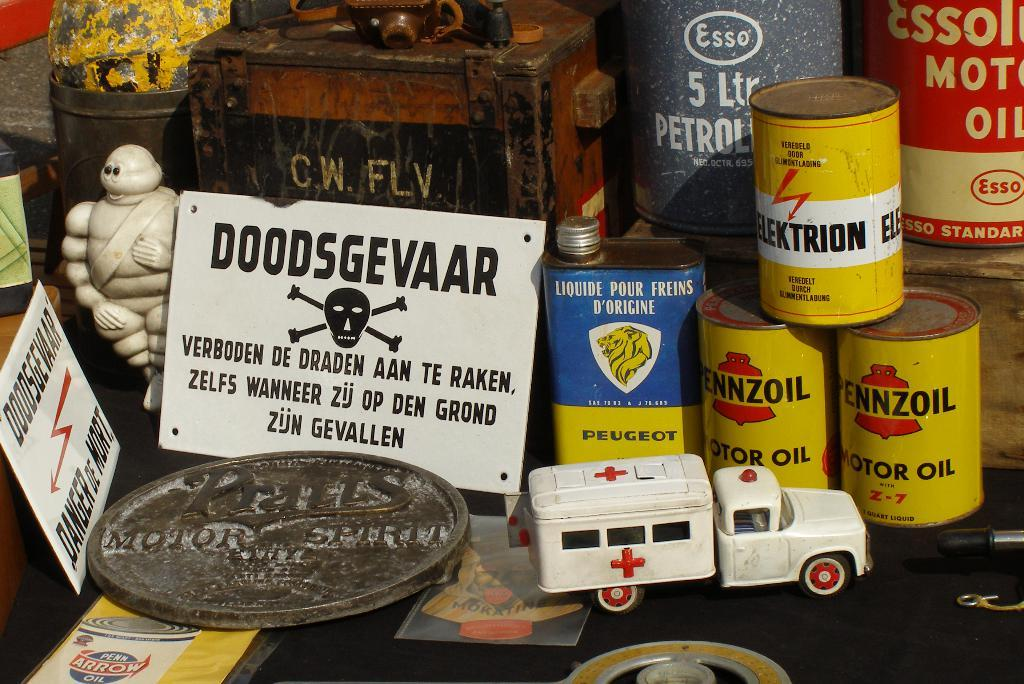<image>
Give a short and clear explanation of the subsequent image. Several cans of Pennzoil are stacked amongst other vehicle collectibles. 